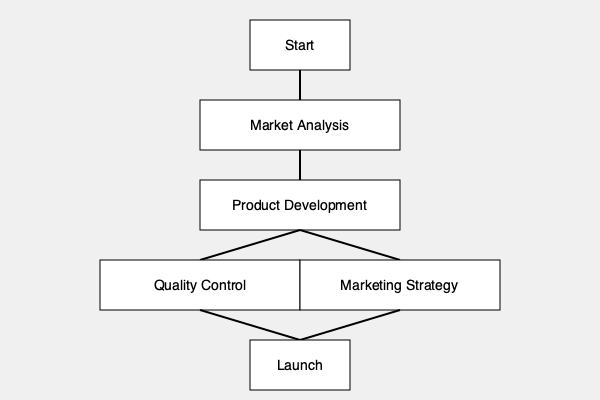In the given business flowchart, which critical step ensures the product meets customer expectations and company standards before proceeding to the launch phase? To answer this question, we need to analyze the flowchart step-by-step:

1. The flowchart starts with "Market Analysis," which is crucial for understanding customer needs and market trends.

2. This is followed by "Product Development," where the actual product is created based on the market analysis.

3. After product development, the flowchart splits into two parallel processes:
   a. Quality Control
   b. Marketing Strategy

4. Both of these processes then converge to the final "Launch" phase.

5. Among these steps, "Quality Control" is the critical step that ensures the product meets customer expectations and company standards.

6. Quality Control typically involves:
   - Testing the product for functionality
   - Checking for defects
   - Ensuring compliance with industry standards
   - Verifying that the product meets the specifications determined during the market analysis and product development phases

7. By performing Quality Control before the launch, the company can ensure that only products meeting the required standards reach the market, thus maintaining the company's reputation and customer satisfaction.

Therefore, the critical step that ensures the product meets expectations and standards before launch is Quality Control.
Answer: Quality Control 